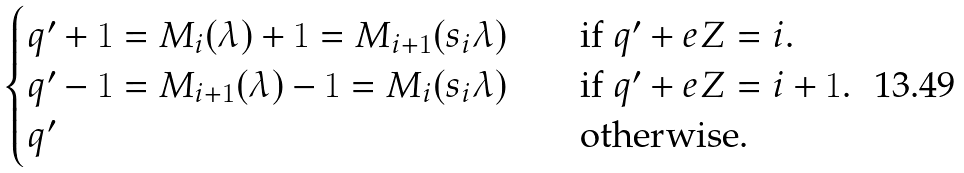<formula> <loc_0><loc_0><loc_500><loc_500>\begin{cases} q ^ { \prime } + 1 = M _ { i } ( \lambda ) + 1 = M _ { i + 1 } ( s _ { i } \lambda ) \quad & \text {if $q^{\prime}+e\mathbb{ }Z=i$.} \\ q ^ { \prime } - 1 = M _ { i + 1 } ( \lambda ) - 1 = M _ { i } ( s _ { i } \lambda ) \quad & \text {if $q^{\prime}+e\mathbb{ }Z=i+1$.} \\ q ^ { \prime } \quad & \text {otherwise.} \end{cases}</formula> 